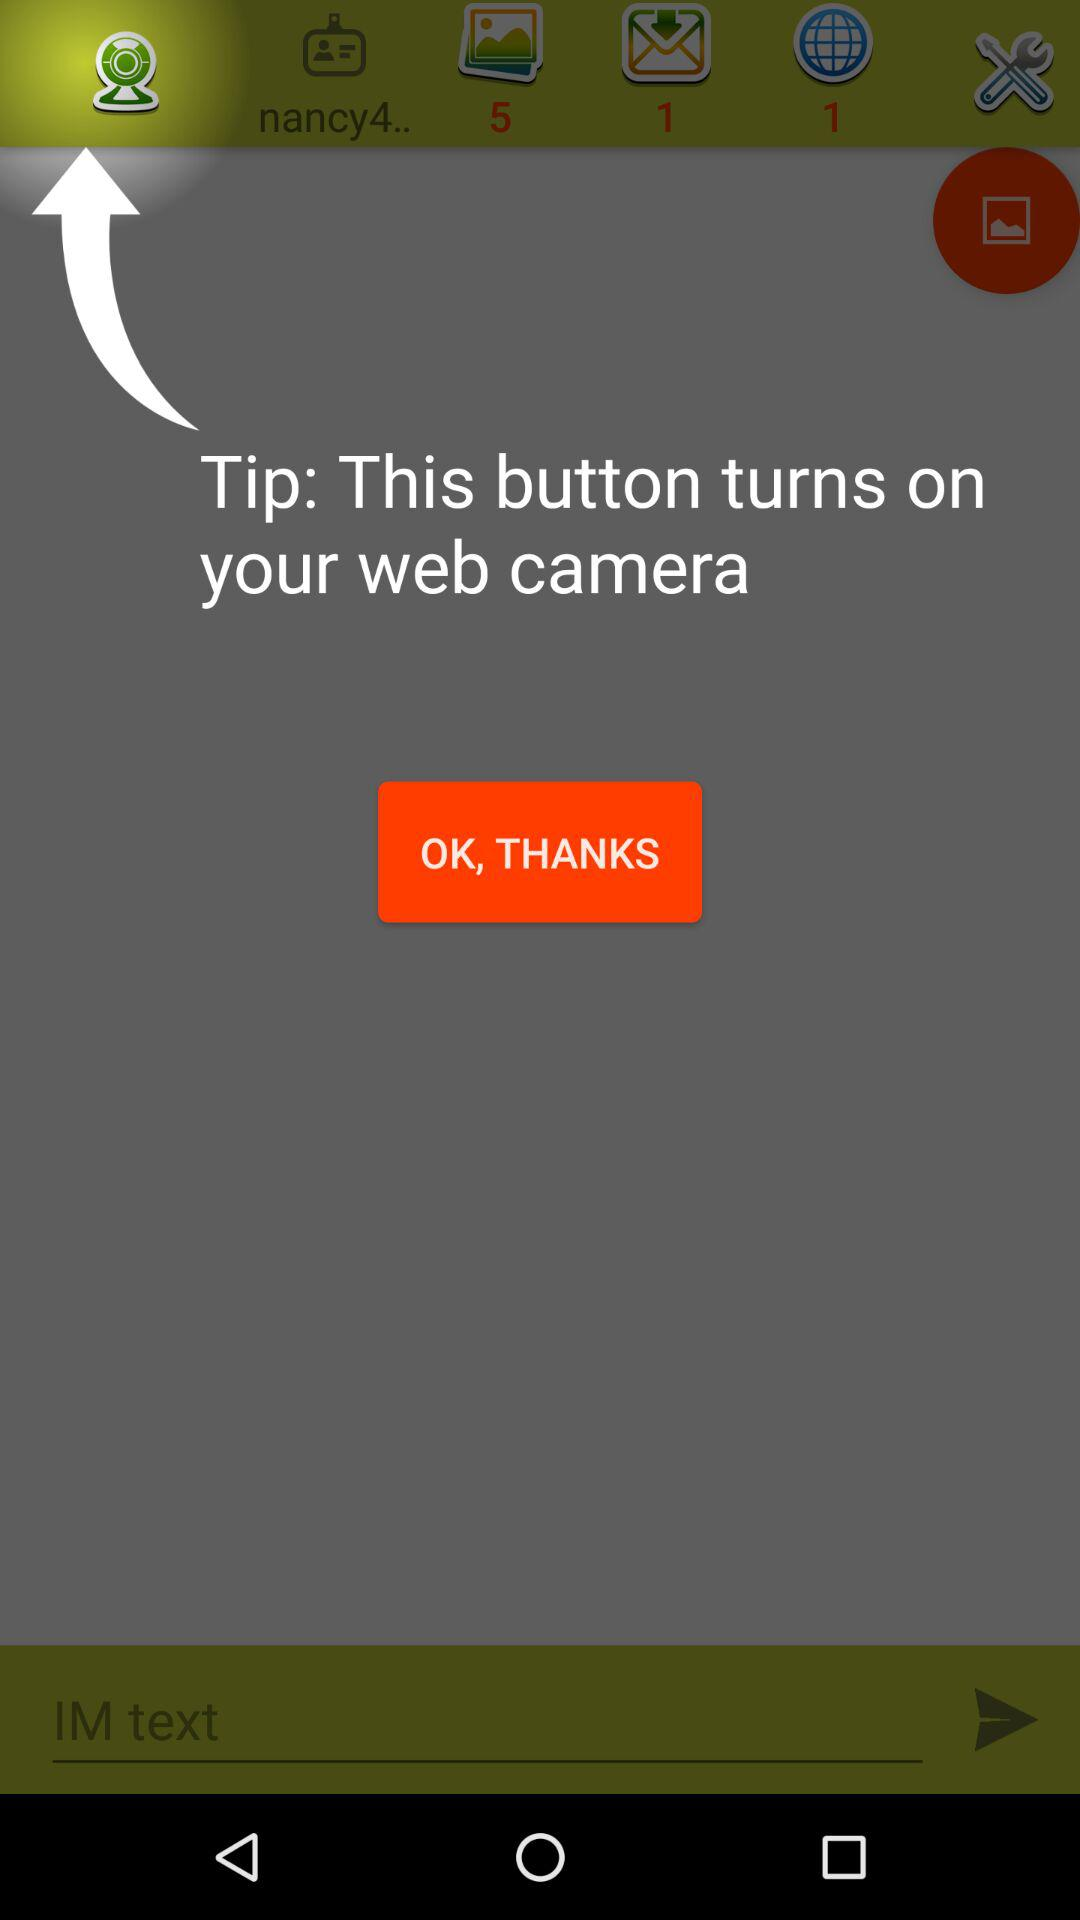What does this button do? This button turns on the web camera. 